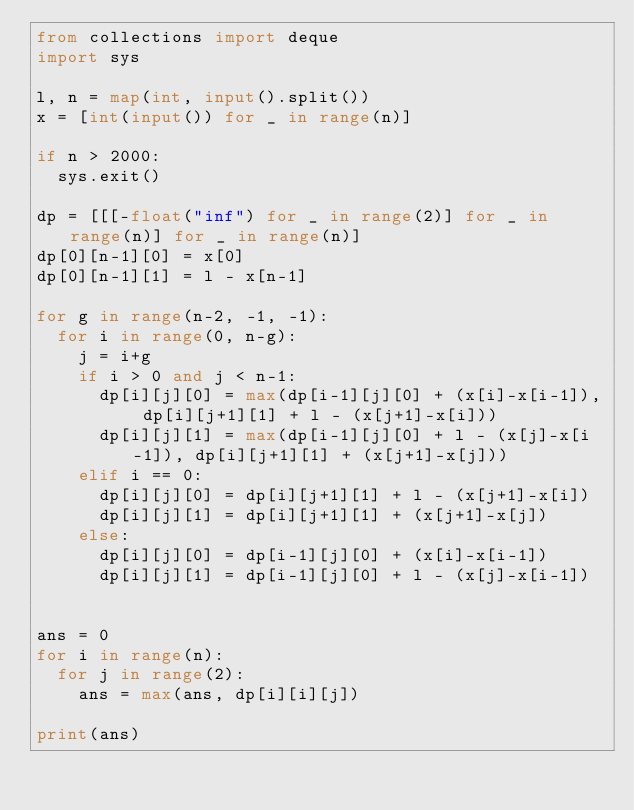<code> <loc_0><loc_0><loc_500><loc_500><_Python_>from collections import deque
import sys

l, n = map(int, input().split())
x = [int(input()) for _ in range(n)]

if n > 2000:
	sys.exit()

dp = [[[-float("inf") for _ in range(2)] for _ in range(n)] for _ in range(n)]
dp[0][n-1][0] = x[0]
dp[0][n-1][1] = l - x[n-1]

for g in range(n-2, -1, -1):
	for i in range(0, n-g):
		j = i+g
		if i > 0 and j < n-1:
			dp[i][j][0] = max(dp[i-1][j][0] + (x[i]-x[i-1]), dp[i][j+1][1] + l - (x[j+1]-x[i]))
			dp[i][j][1] = max(dp[i-1][j][0] + l - (x[j]-x[i-1]), dp[i][j+1][1] + (x[j+1]-x[j]))
		elif i == 0:
			dp[i][j][0] = dp[i][j+1][1] + l - (x[j+1]-x[i])
			dp[i][j][1] = dp[i][j+1][1] + (x[j+1]-x[j])
		else:
			dp[i][j][0] = dp[i-1][j][0] + (x[i]-x[i-1])
			dp[i][j][1] = dp[i-1][j][0] + l - (x[j]-x[i-1])


ans = 0
for i in range(n):
	for j in range(2):
		ans = max(ans, dp[i][i][j])

print(ans)</code> 